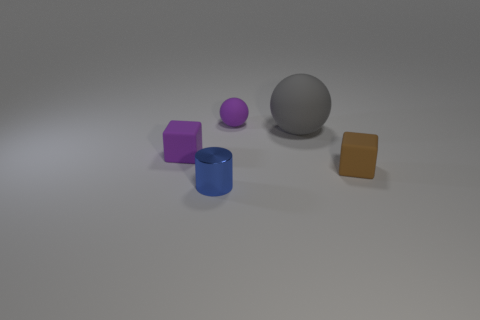Is there any other thing that has the same material as the blue object?
Keep it short and to the point. No. There is a tiny rubber ball; is it the same color as the cube left of the tiny brown rubber thing?
Provide a succinct answer. Yes. There is a gray rubber object behind the purple thing that is in front of the small purple ball behind the brown rubber thing; how big is it?
Offer a very short reply. Large. What number of other tiny metal cylinders have the same color as the metal cylinder?
Ensure brevity in your answer.  0. What number of things are blue metal things or objects behind the blue cylinder?
Your answer should be compact. 5. The small metal cylinder is what color?
Give a very brief answer. Blue. There is a tiny matte object left of the tiny metallic cylinder; what color is it?
Your answer should be very brief. Purple. There is a purple rubber thing that is on the right side of the small metallic cylinder; what number of large balls are in front of it?
Your response must be concise. 1. Is the size of the purple ball the same as the rubber block right of the tiny purple rubber cube?
Offer a terse response. Yes. Is there a cylinder that has the same size as the purple cube?
Your response must be concise. Yes. 